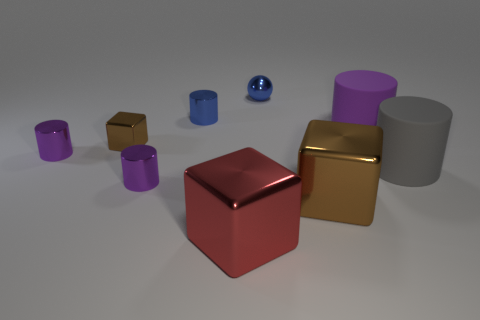Are there any large purple cylinders to the left of the small cube?
Make the answer very short. No. There is a tiny purple shiny object behind the gray rubber thing; what number of small brown things are left of it?
Offer a terse response. 0. There is a ball that is made of the same material as the blue cylinder; what is its size?
Provide a succinct answer. Small. How big is the red block?
Offer a terse response. Large. Does the small blue cylinder have the same material as the gray cylinder?
Your answer should be very brief. No. What number of cylinders are tiny red matte objects or small brown things?
Offer a terse response. 0. The big metallic block behind the metal thing that is in front of the big brown shiny thing is what color?
Make the answer very short. Brown. There is a object that is the same color as the tiny cube; what is its size?
Ensure brevity in your answer.  Large. How many metallic cubes are to the left of the metal object in front of the big cube right of the small blue ball?
Provide a short and direct response. 1. There is a metallic object on the right side of the blue metal ball; is it the same shape as the big metal thing that is left of the blue sphere?
Offer a terse response. Yes. 